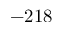Convert formula to latex. <formula><loc_0><loc_0><loc_500><loc_500>- 2 1 8</formula> 